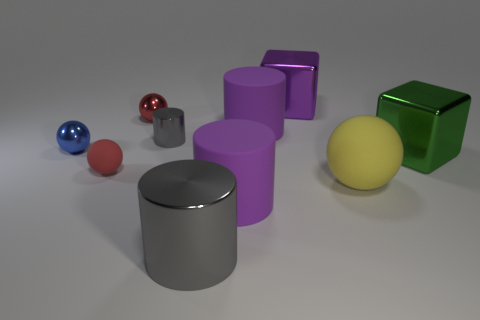Subtract all large cylinders. How many cylinders are left? 1 Subtract all purple cylinders. How many cylinders are left? 2 Subtract all cylinders. How many objects are left? 6 Subtract 2 cubes. How many cubes are left? 0 Subtract all large green objects. Subtract all red metallic objects. How many objects are left? 8 Add 8 big purple cylinders. How many big purple cylinders are left? 10 Add 9 small yellow matte things. How many small yellow matte things exist? 9 Subtract 0 brown cubes. How many objects are left? 10 Subtract all green spheres. Subtract all yellow cylinders. How many spheres are left? 4 Subtract all blue cylinders. How many red cubes are left? 0 